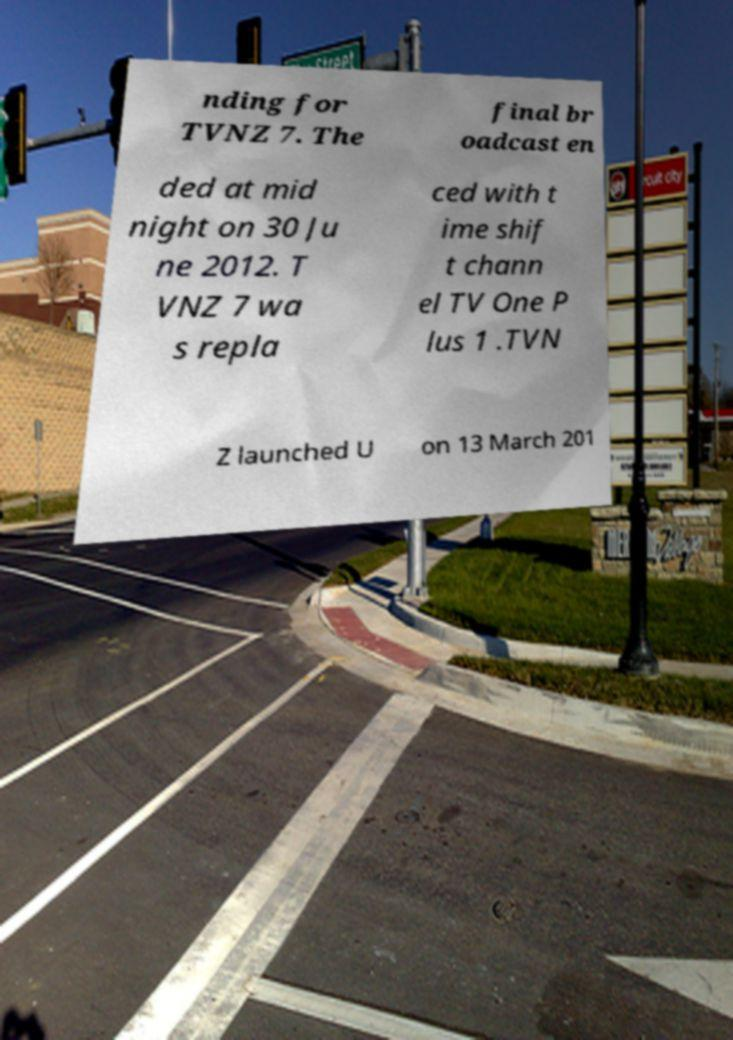Can you read and provide the text displayed in the image?This photo seems to have some interesting text. Can you extract and type it out for me? nding for TVNZ 7. The final br oadcast en ded at mid night on 30 Ju ne 2012. T VNZ 7 wa s repla ced with t ime shif t chann el TV One P lus 1 .TVN Z launched U on 13 March 201 